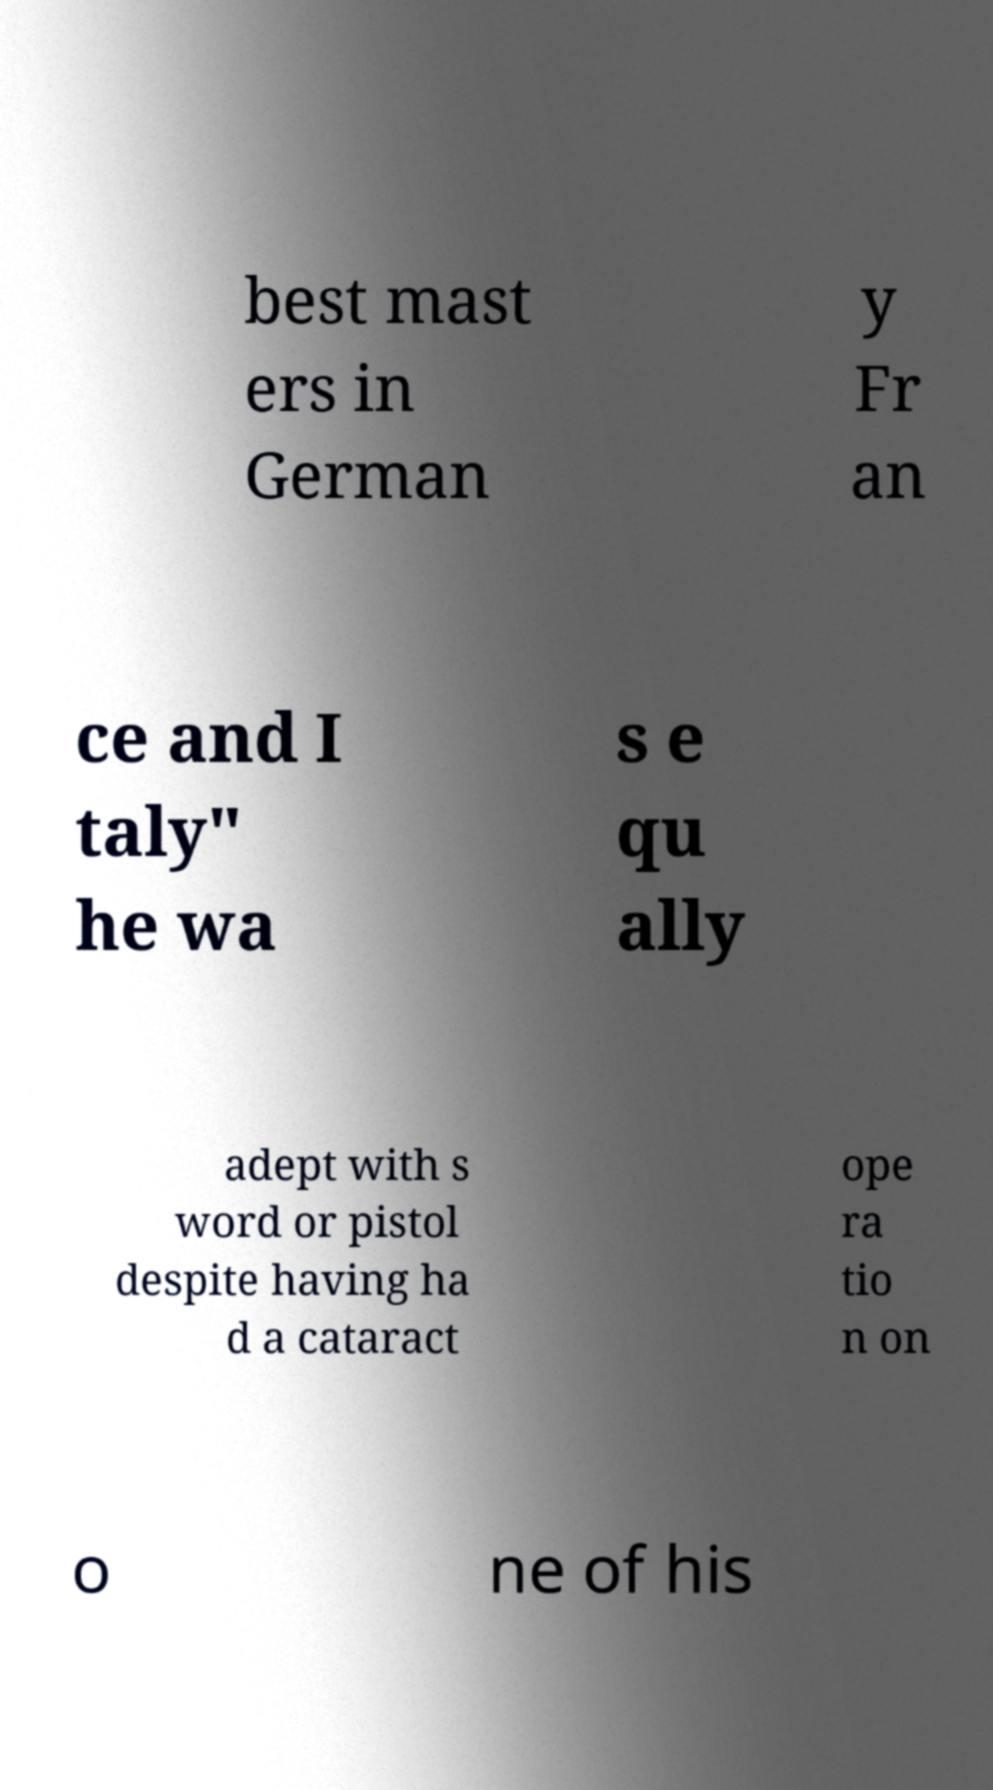Please read and relay the text visible in this image. What does it say? best mast ers in German y Fr an ce and I taly" he wa s e qu ally adept with s word or pistol despite having ha d a cataract ope ra tio n on o ne of his 